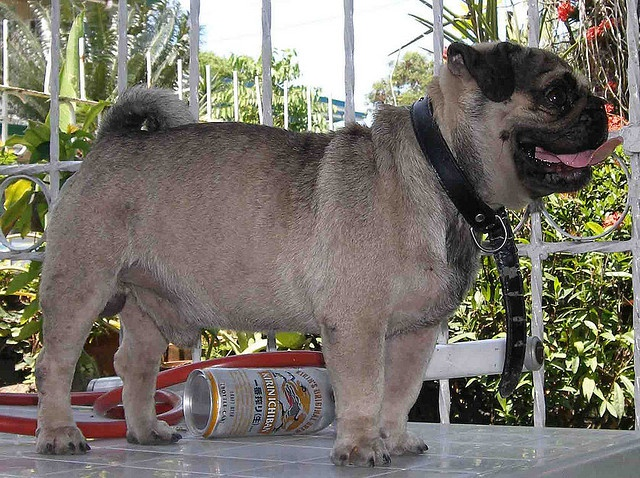Describe the objects in this image and their specific colors. I can see dog in gray and black tones and dining table in gray tones in this image. 